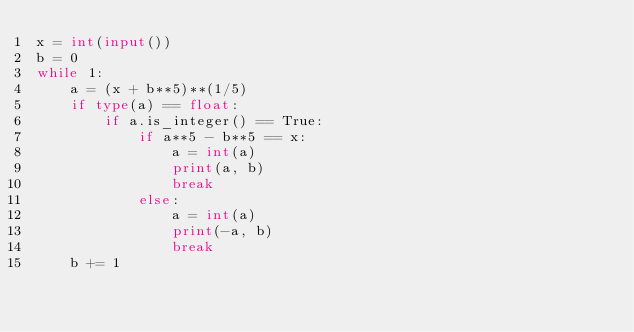Convert code to text. <code><loc_0><loc_0><loc_500><loc_500><_Python_>x = int(input())
b = 0
while 1:
    a = (x + b**5)**(1/5)
    if type(a) == float:
        if a.is_integer() == True:
            if a**5 - b**5 == x:
                a = int(a)
                print(a, b)
                break
            else:
                a = int(a)
                print(-a, b)
                break
    b += 1</code> 